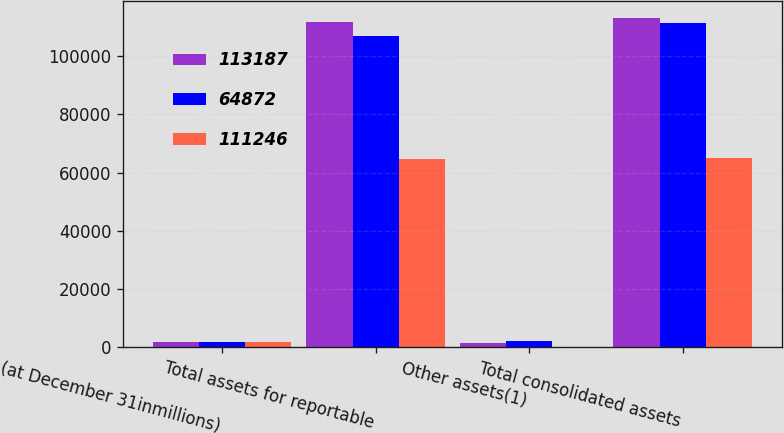Convert chart. <chart><loc_0><loc_0><loc_500><loc_500><stacked_bar_chart><ecel><fcel>(at December 31inmillions)<fcel>Total assets for reportable<fcel>Other assets(1)<fcel>Total consolidated assets<nl><fcel>113187<fcel>2005<fcel>111806<fcel>1381<fcel>113187<nl><fcel>64872<fcel>2004<fcel>106861<fcel>2344<fcel>111246<nl><fcel>111246<fcel>2003<fcel>64573<fcel>299<fcel>64872<nl></chart> 